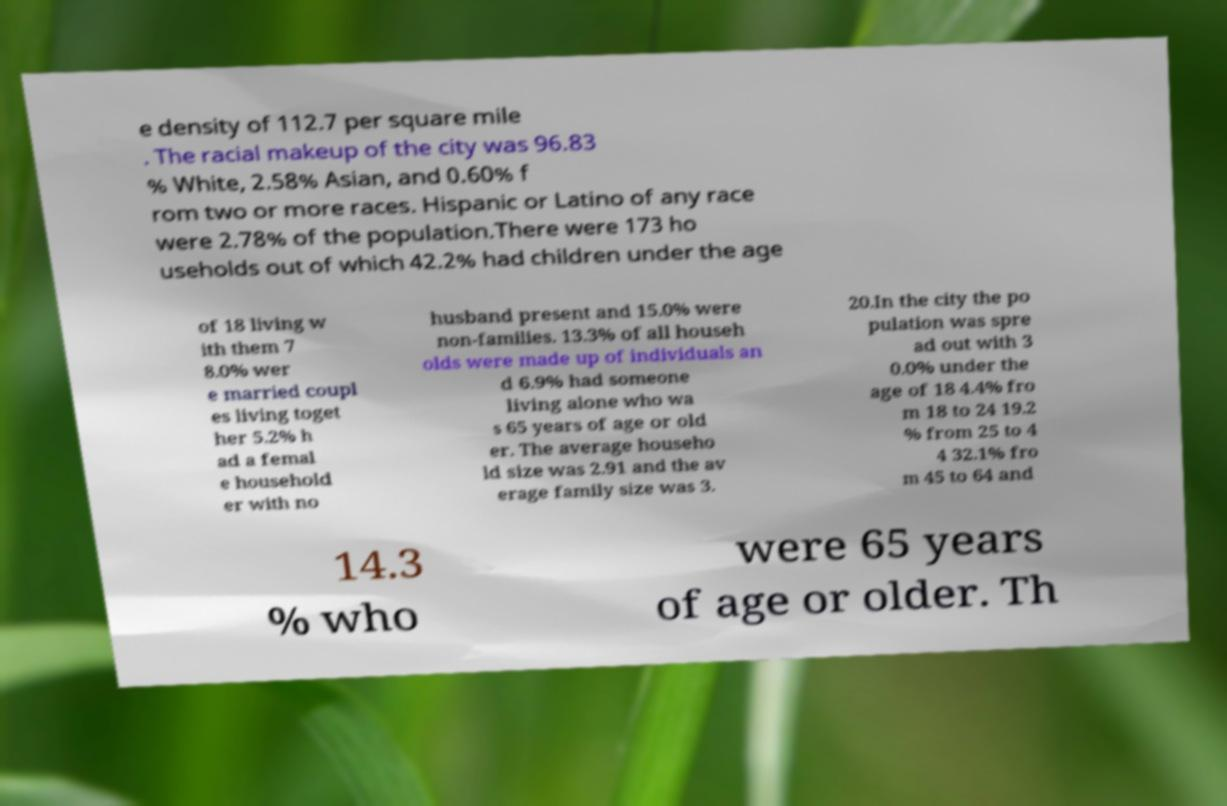Could you extract and type out the text from this image? e density of 112.7 per square mile . The racial makeup of the city was 96.83 % White, 2.58% Asian, and 0.60% f rom two or more races. Hispanic or Latino of any race were 2.78% of the population.There were 173 ho useholds out of which 42.2% had children under the age of 18 living w ith them 7 8.0% wer e married coupl es living toget her 5.2% h ad a femal e household er with no husband present and 15.0% were non-families. 13.3% of all househ olds were made up of individuals an d 6.9% had someone living alone who wa s 65 years of age or old er. The average househo ld size was 2.91 and the av erage family size was 3. 20.In the city the po pulation was spre ad out with 3 0.0% under the age of 18 4.4% fro m 18 to 24 19.2 % from 25 to 4 4 32.1% fro m 45 to 64 and 14.3 % who were 65 years of age or older. Th 